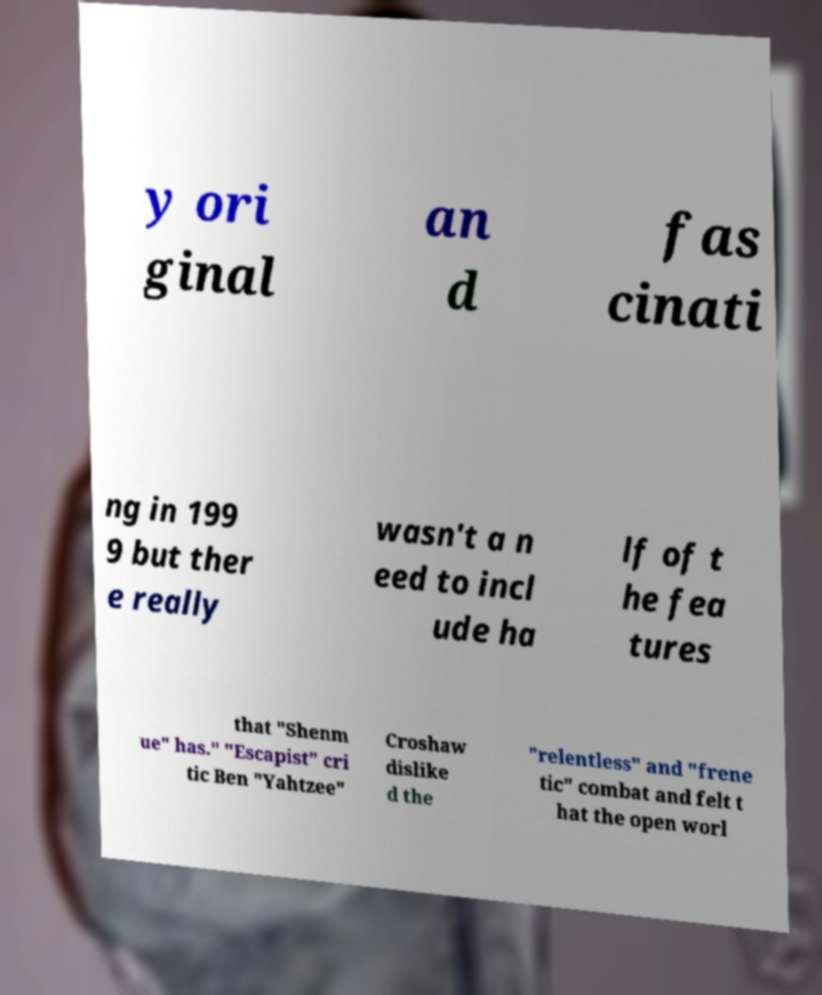For documentation purposes, I need the text within this image transcribed. Could you provide that? y ori ginal an d fas cinati ng in 199 9 but ther e really wasn't a n eed to incl ude ha lf of t he fea tures that "Shenm ue" has." "Escapist" cri tic Ben "Yahtzee" Croshaw dislike d the "relentless" and "frene tic" combat and felt t hat the open worl 